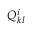<formula> <loc_0><loc_0><loc_500><loc_500>Q _ { k l } ^ { i }</formula> 